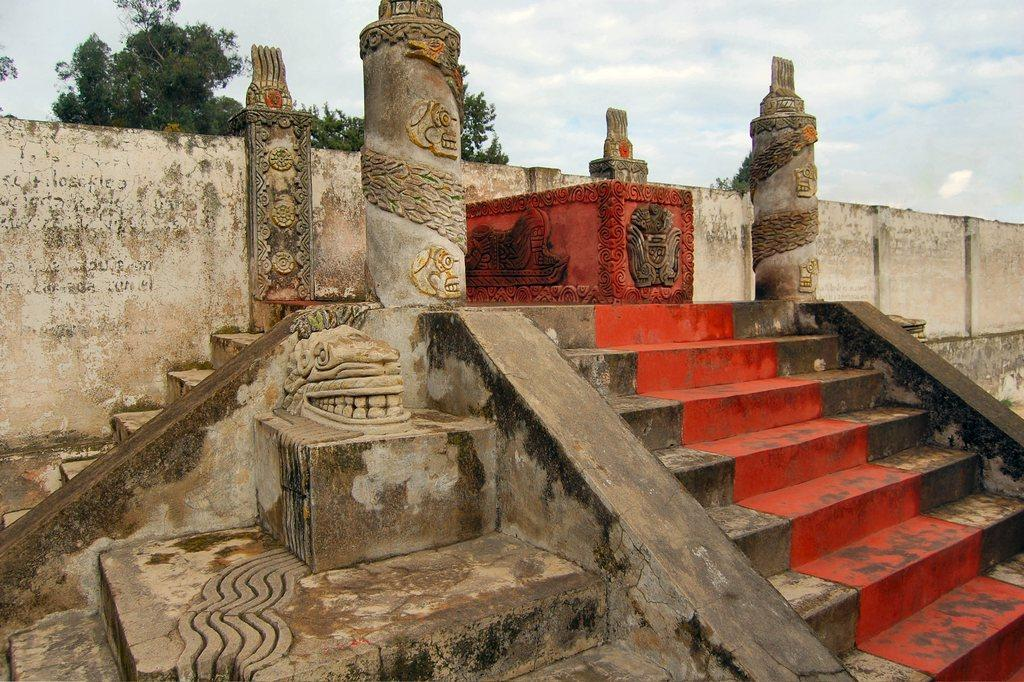What is located in the middle of the image? There are steps in the middle of the image. What is behind the steps? There is a wall behind the steps. What can be seen behind the wall? Trees are visible behind the wall. What is visible in the background of the image? Clouds and the sky are present in the background. How many gold nails can be seen in the image? There are no gold nails present in the image. Is there a beggar visible in the image? There is no beggar present in the image. 